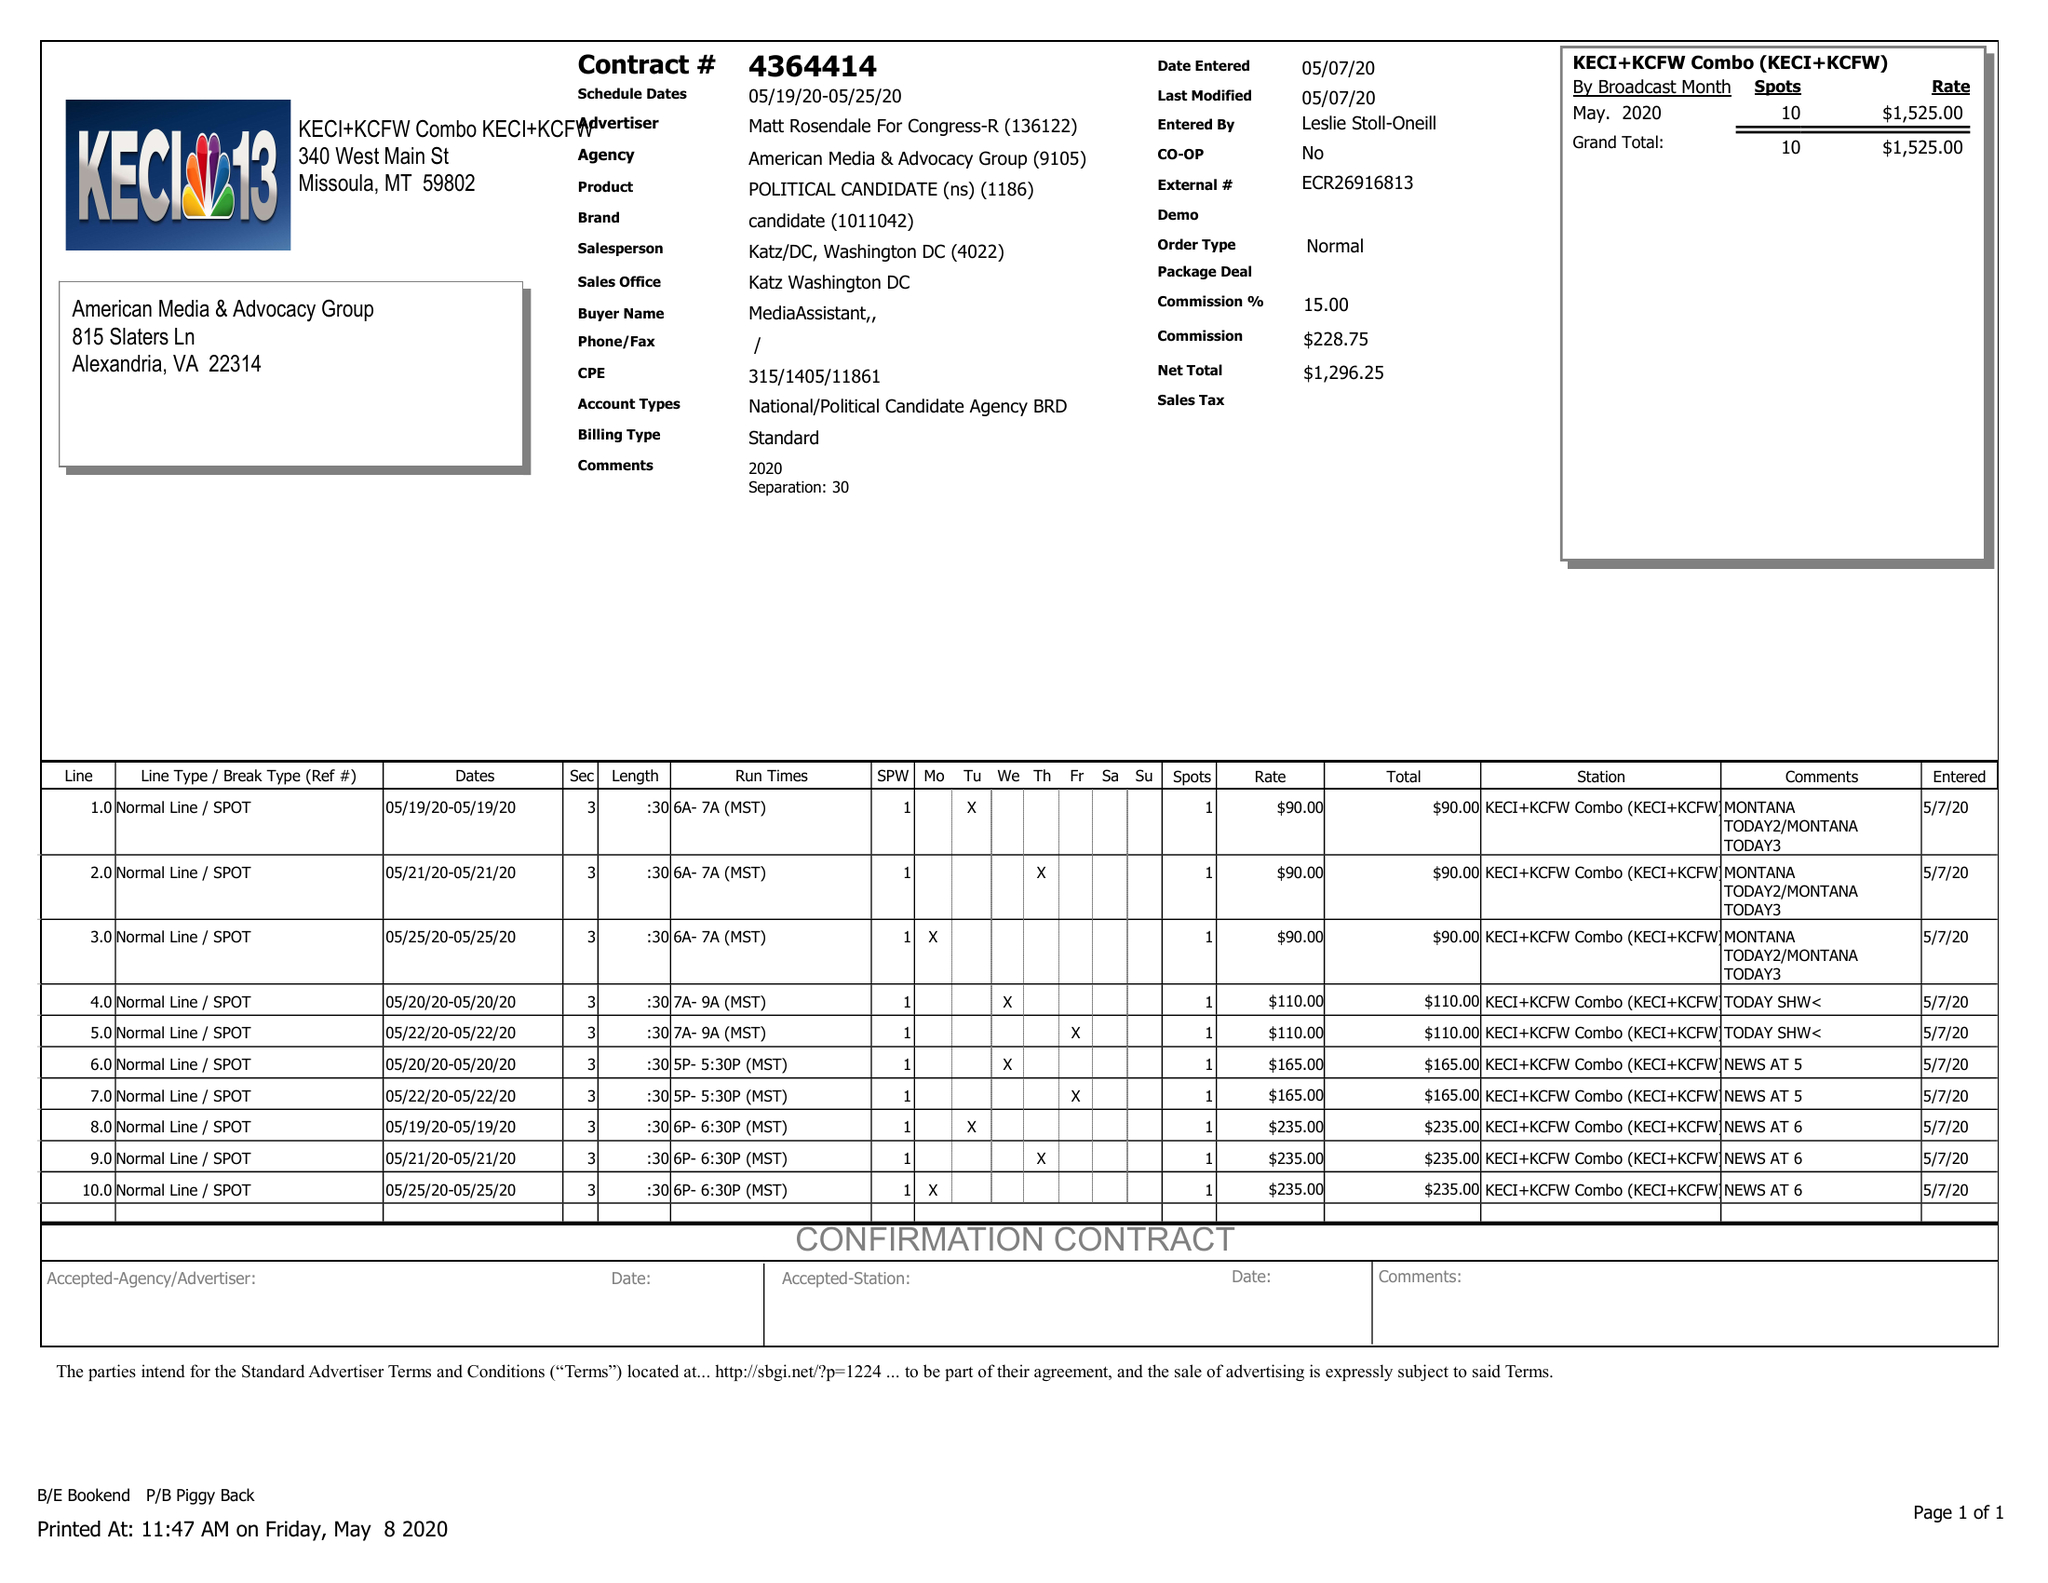What is the value for the contract_num?
Answer the question using a single word or phrase. 4364414 